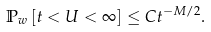Convert formula to latex. <formula><loc_0><loc_0><loc_500><loc_500>{ \mathbb { P } } _ { w } \left [ t < U < \infty \right ] \leq C t ^ { - M / 2 } .</formula> 